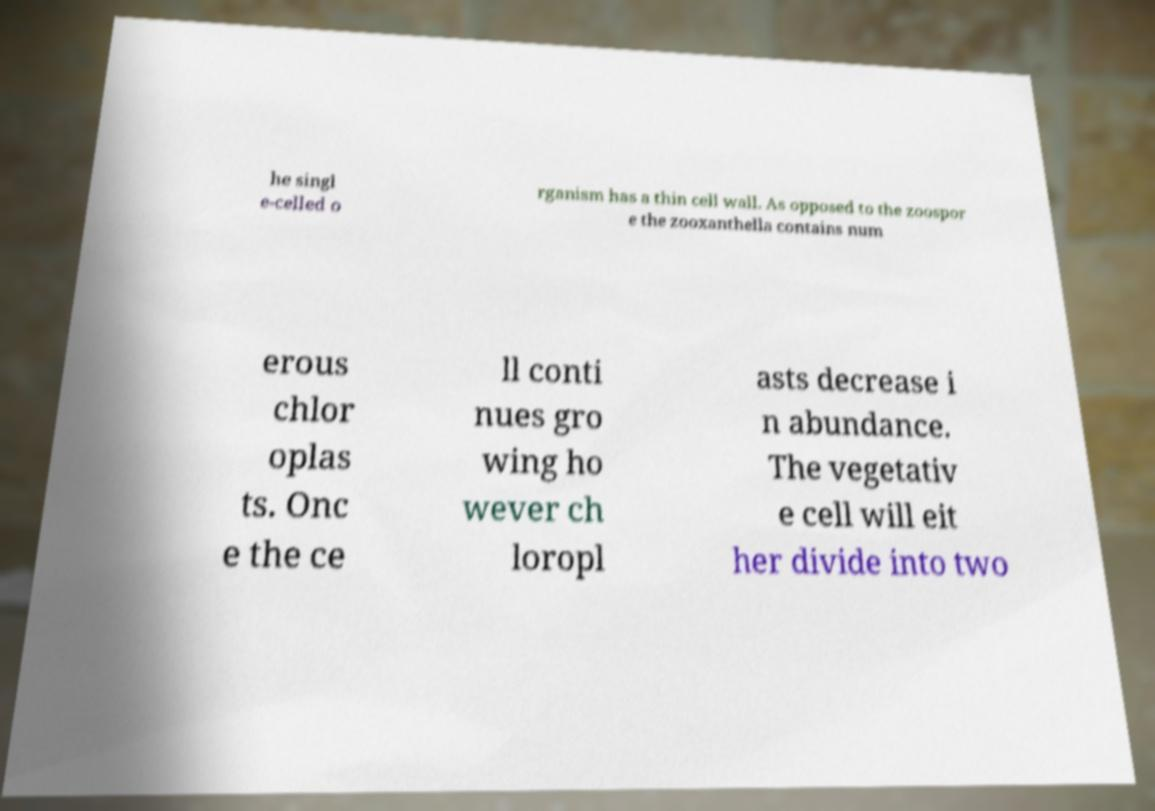Could you extract and type out the text from this image? he singl e-celled o rganism has a thin cell wall. As opposed to the zoospor e the zooxanthella contains num erous chlor oplas ts. Onc e the ce ll conti nues gro wing ho wever ch loropl asts decrease i n abundance. The vegetativ e cell will eit her divide into two 